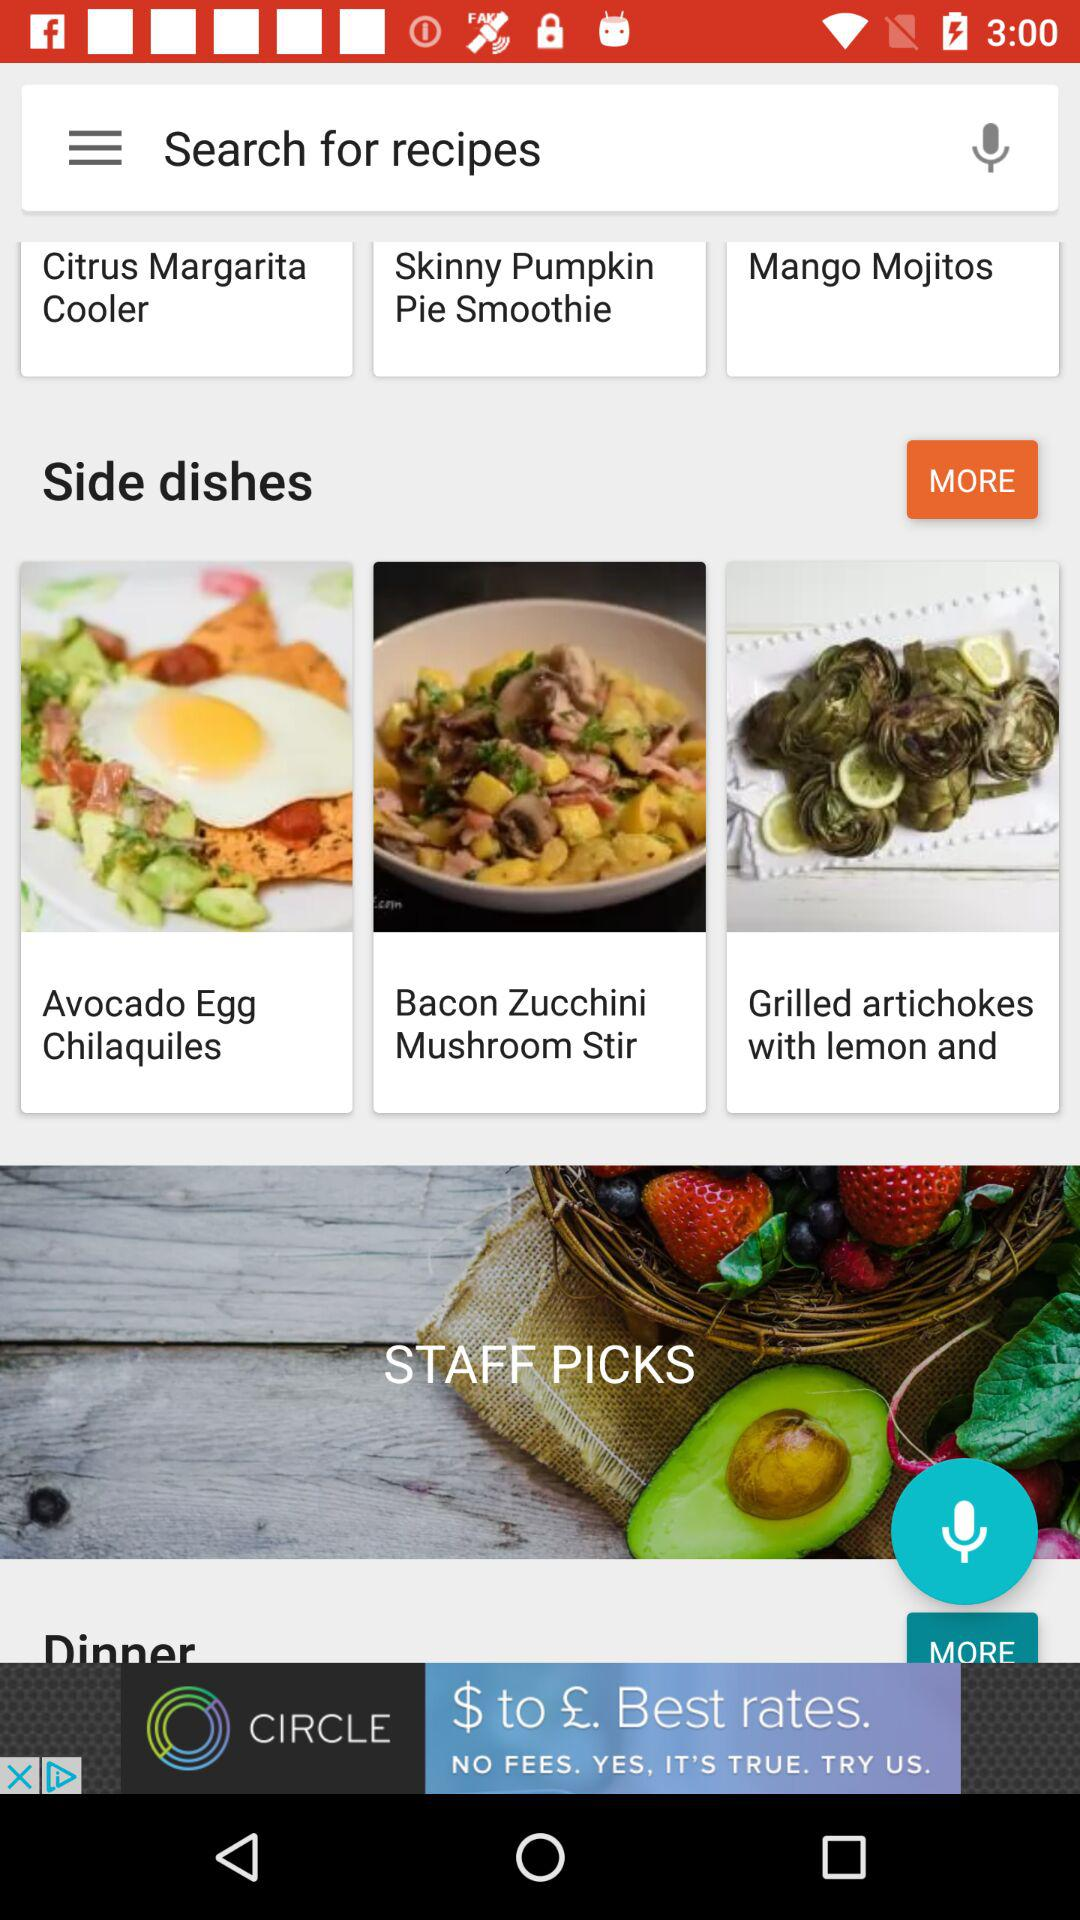How many calories are in "Mango Mojitos"?
When the provided information is insufficient, respond with <no answer>. <no answer> 